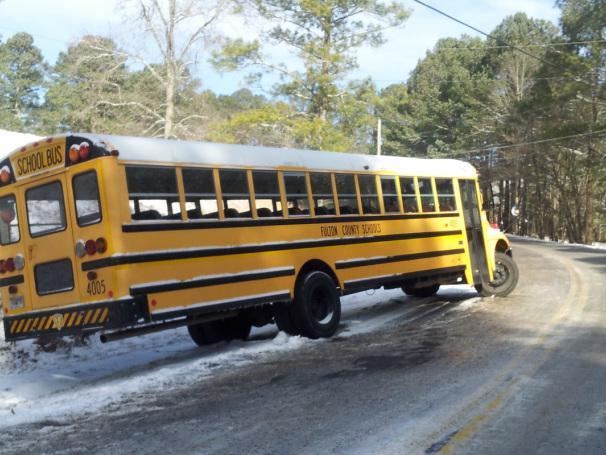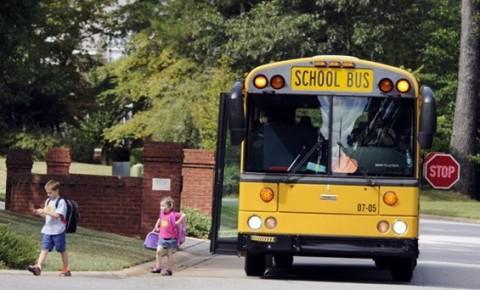The first image is the image on the left, the second image is the image on the right. Considering the images on both sides, is "The front of the buses in both pictures are facing the left of the picture." valid? Answer yes or no. No. The first image is the image on the left, the second image is the image on the right. For the images displayed, is the sentence "One of the images shows a school bus with its stop sign extended and the other image shows a school bus without an extended stop sign." factually correct? Answer yes or no. Yes. 